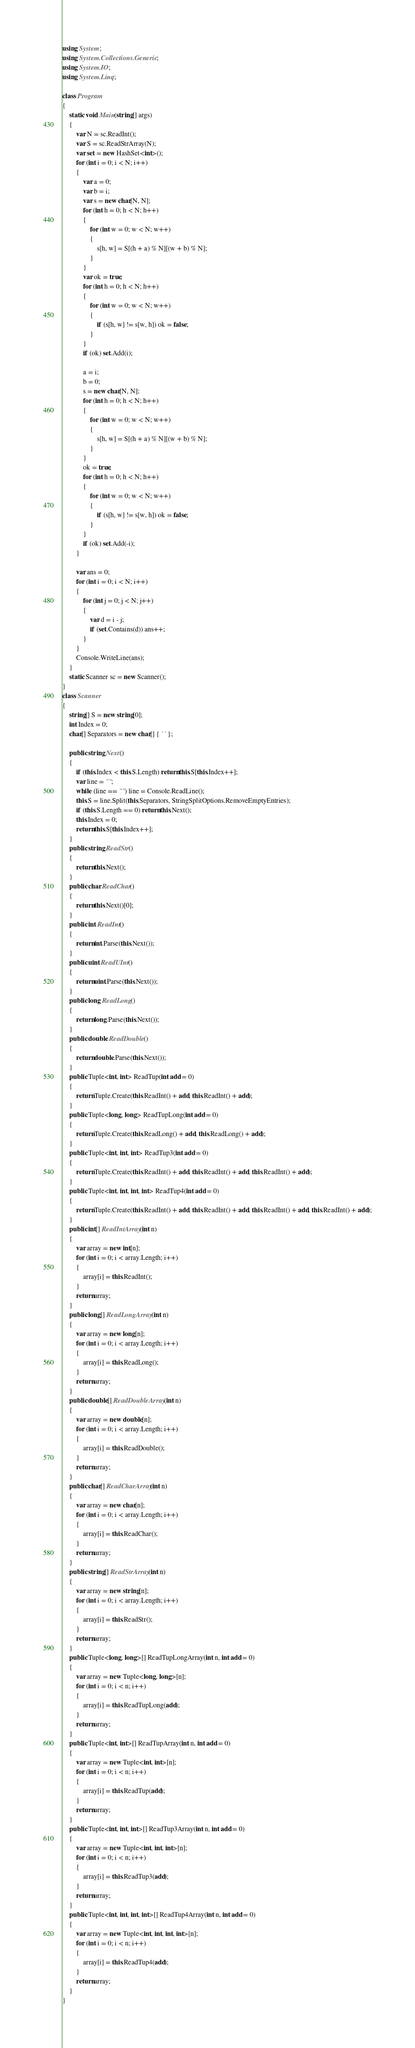Convert code to text. <code><loc_0><loc_0><loc_500><loc_500><_C#_>using System;
using System.Collections.Generic;
using System.IO;
using System.Linq;

class Program
{
    static void Main(string[] args)
    {
        var N = sc.ReadInt();
        var S = sc.ReadStrArray(N);
        var set = new HashSet<int>();
        for (int i = 0; i < N; i++)
        {
            var a = 0;
            var b = i;
            var s = new char[N, N];
            for (int h = 0; h < N; h++)
            {
                for (int w = 0; w < N; w++)
                {
                    s[h, w] = S[(h + a) % N][(w + b) % N];
                }
            }
            var ok = true;
            for (int h = 0; h < N; h++)
            {
                for (int w = 0; w < N; w++)
                {
                    if (s[h, w] != s[w, h]) ok = false;
                }
            }
            if (ok) set.Add(i);

            a = i;
            b = 0;
            s = new char[N, N];
            for (int h = 0; h < N; h++)
            {
                for (int w = 0; w < N; w++)
                {
                    s[h, w] = S[(h + a) % N][(w + b) % N];
                }
            }
            ok = true;
            for (int h = 0; h < N; h++)
            {
                for (int w = 0; w < N; w++)
                {
                    if (s[h, w] != s[w, h]) ok = false;
                }
            }
            if (ok) set.Add(-i);
        }

        var ans = 0;
        for (int i = 0; i < N; i++)
        {
            for (int j = 0; j < N; j++)
            {
                var d = i - j;
                if (set.Contains(d)) ans++;
            }
        }
        Console.WriteLine(ans);
    }
    static Scanner sc = new Scanner();
}
class Scanner
{
    string[] S = new string[0];
    int Index = 0;
    char[] Separators = new char[] { ' ' };

    public string Next()
    {
        if (this.Index < this.S.Length) return this.S[this.Index++];
        var line = "";
        while (line == "") line = Console.ReadLine();
        this.S = line.Split(this.Separators, StringSplitOptions.RemoveEmptyEntries);
        if (this.S.Length == 0) return this.Next();
        this.Index = 0;
        return this.S[this.Index++];
    }
    public string ReadStr()
    {
        return this.Next();
    }
    public char ReadChar()
    {
        return this.Next()[0];
    }
    public int ReadInt()
    {
        return int.Parse(this.Next());
    }
    public uint ReadUInt()
    {
        return uint.Parse(this.Next());
    }
    public long ReadLong()
    {
        return long.Parse(this.Next());
    }
    public double ReadDouble()
    {
        return double.Parse(this.Next());
    }
    public Tuple<int, int> ReadTup(int add = 0)
    {
        return Tuple.Create(this.ReadInt() + add, this.ReadInt() + add);
    }
    public Tuple<long, long> ReadTupLong(int add = 0)
    {
        return Tuple.Create(this.ReadLong() + add, this.ReadLong() + add);
    }
    public Tuple<int, int, int> ReadTup3(int add = 0)
    {
        return Tuple.Create(this.ReadInt() + add, this.ReadInt() + add, this.ReadInt() + add);
    }
    public Tuple<int, int, int, int> ReadTup4(int add = 0)
    {
        return Tuple.Create(this.ReadInt() + add, this.ReadInt() + add, this.ReadInt() + add, this.ReadInt() + add);
    }
    public int[] ReadIntArray(int n)
    {
        var array = new int[n];
        for (int i = 0; i < array.Length; i++)
        {
            array[i] = this.ReadInt();
        }
        return array;
    }
    public long[] ReadLongArray(int n)
    {
        var array = new long[n];
        for (int i = 0; i < array.Length; i++)
        {
            array[i] = this.ReadLong();
        }
        return array;
    }
    public double[] ReadDoubleArray(int n)
    {
        var array = new double[n];
        for (int i = 0; i < array.Length; i++)
        {
            array[i] = this.ReadDouble();
        }
        return array;
    }
    public char[] ReadCharArray(int n)
    {
        var array = new char[n];
        for (int i = 0; i < array.Length; i++)
        {
            array[i] = this.ReadChar();
        }
        return array;
    }
    public string[] ReadStrArray(int n)
    {
        var array = new string[n];
        for (int i = 0; i < array.Length; i++)
        {
            array[i] = this.ReadStr();
        }
        return array;
    }
    public Tuple<long, long>[] ReadTupLongArray(int n, int add = 0)
    {
        var array = new Tuple<long, long>[n];
        for (int i = 0; i < n; i++)
        {
            array[i] = this.ReadTupLong(add);
        }
        return array;
    }
    public Tuple<int, int>[] ReadTupArray(int n, int add = 0)
    {
        var array = new Tuple<int, int>[n];
        for (int i = 0; i < n; i++)
        {
            array[i] = this.ReadTup(add);
        }
        return array;
    }
    public Tuple<int, int, int>[] ReadTup3Array(int n, int add = 0)
    {
        var array = new Tuple<int, int, int>[n];
        for (int i = 0; i < n; i++)
        {
            array[i] = this.ReadTup3(add);
        }
        return array;
    }
    public Tuple<int, int, int, int>[] ReadTup4Array(int n, int add = 0)
    {
        var array = new Tuple<int, int, int, int>[n];
        for (int i = 0; i < n; i++)
        {
            array[i] = this.ReadTup4(add);
        }
        return array;
    }
}
</code> 